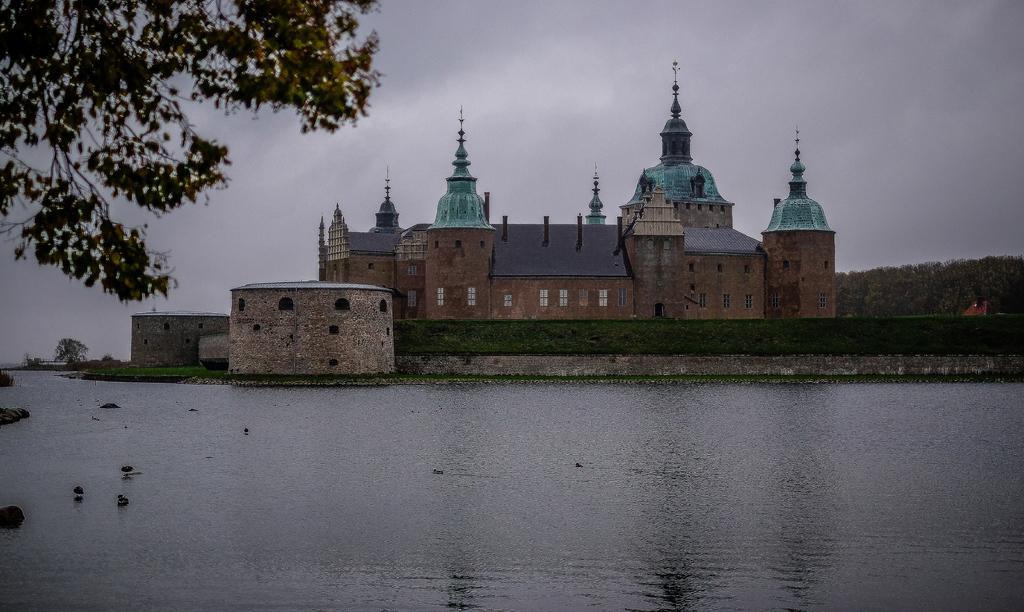What can be seen in the left top corner of the image? There is a branch of a tree in the left top corner of the image. What is visible in the image besides the tree branch? There is water, a building with windows, trees, and the sky visible in the image. Can you describe the building in the background? The building in the background has windows. What is the natural environment visible in the image? The natural environment includes trees and the sky. What type of sack can be seen rubbing against the building in the image? There is no sack present in the image, nor is there any indication of rubbing against the building. 